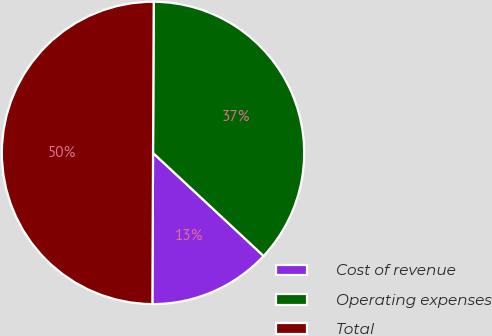<chart> <loc_0><loc_0><loc_500><loc_500><pie_chart><fcel>Cost of revenue<fcel>Operating expenses<fcel>Total<nl><fcel>13.13%<fcel>36.87%<fcel>50.0%<nl></chart> 